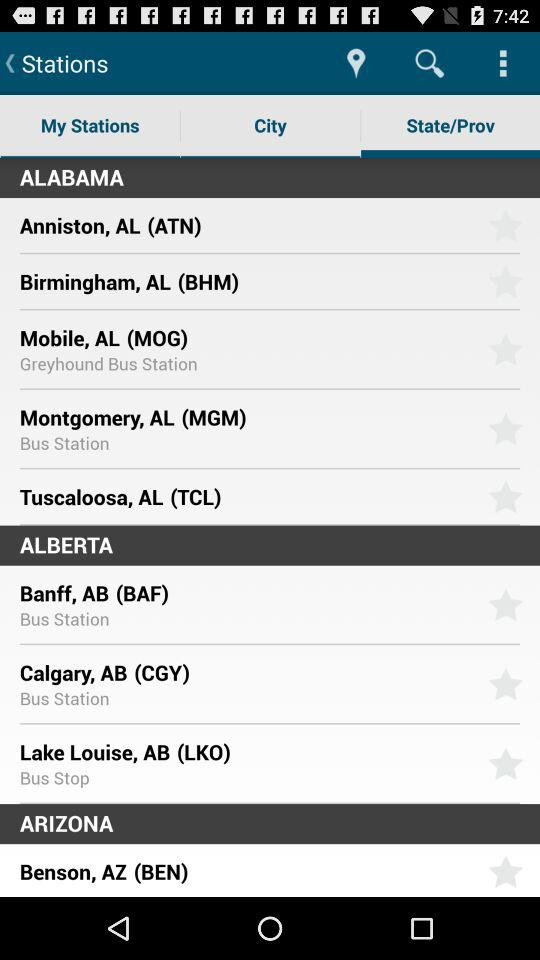What is the location of the "Greyhound Bus Station"? The location is Mobile, AL (MOG). 